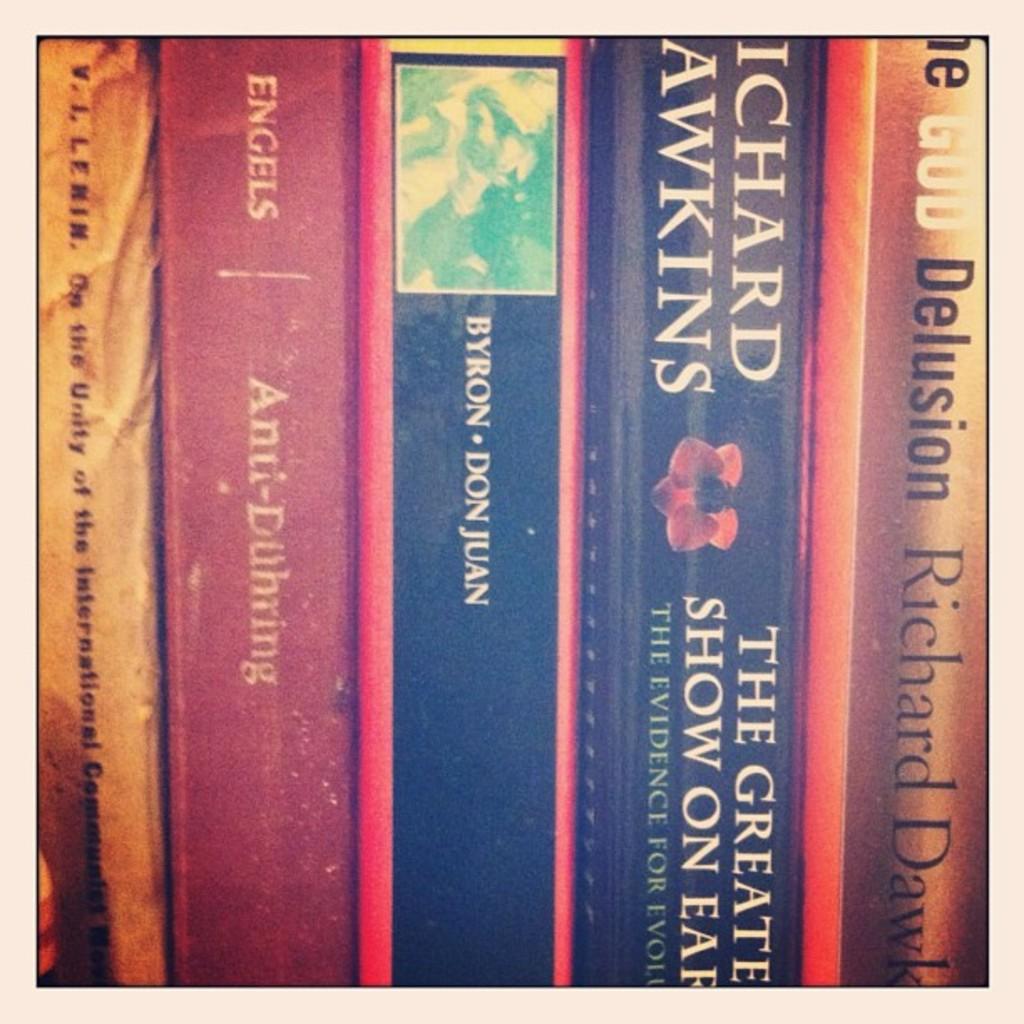What book did richard hawkins write>?
Provide a succinct answer. The greatest show on earth. 